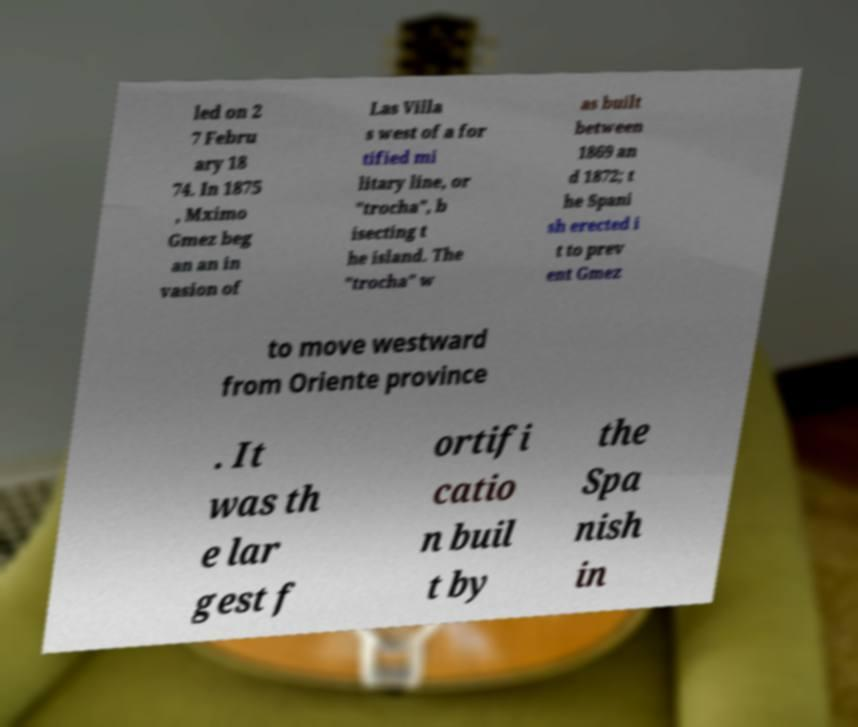Please identify and transcribe the text found in this image. led on 2 7 Febru ary 18 74. In 1875 , Mximo Gmez beg an an in vasion of Las Villa s west of a for tified mi litary line, or "trocha", b isecting t he island. The "trocha" w as built between 1869 an d 1872; t he Spani sh erected i t to prev ent Gmez to move westward from Oriente province . It was th e lar gest f ortifi catio n buil t by the Spa nish in 